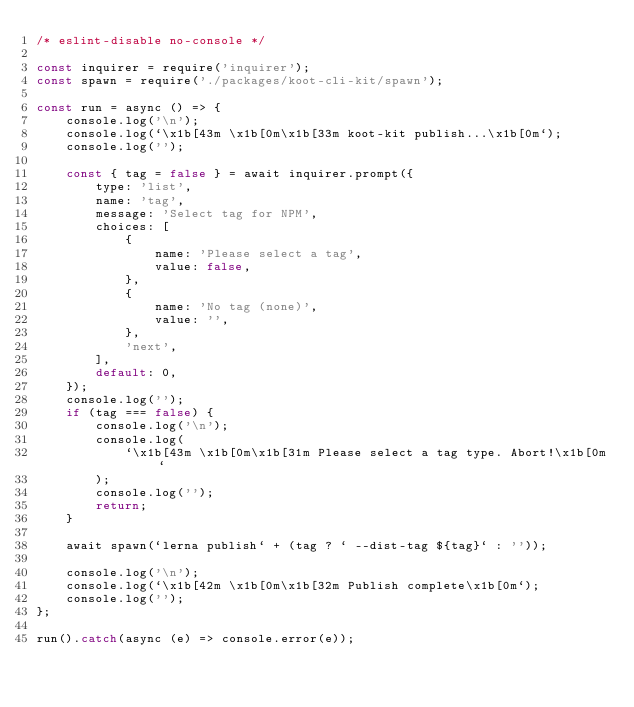Convert code to text. <code><loc_0><loc_0><loc_500><loc_500><_JavaScript_>/* eslint-disable no-console */

const inquirer = require('inquirer');
const spawn = require('./packages/koot-cli-kit/spawn');

const run = async () => {
    console.log('\n');
    console.log(`\x1b[43m \x1b[0m\x1b[33m koot-kit publish...\x1b[0m`);
    console.log('');

    const { tag = false } = await inquirer.prompt({
        type: 'list',
        name: 'tag',
        message: 'Select tag for NPM',
        choices: [
            {
                name: 'Please select a tag',
                value: false,
            },
            {
                name: 'No tag (none)',
                value: '',
            },
            'next',
        ],
        default: 0,
    });
    console.log('');
    if (tag === false) {
        console.log('\n');
        console.log(
            `\x1b[43m \x1b[0m\x1b[31m Please select a tag type. Abort!\x1b[0m`
        );
        console.log('');
        return;
    }

    await spawn(`lerna publish` + (tag ? ` --dist-tag ${tag}` : ''));

    console.log('\n');
    console.log(`\x1b[42m \x1b[0m\x1b[32m Publish complete\x1b[0m`);
    console.log('');
};

run().catch(async (e) => console.error(e));
</code> 